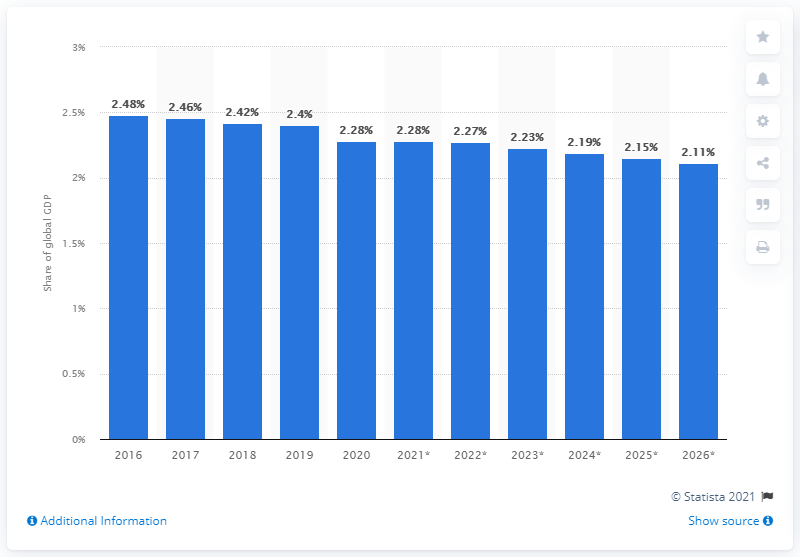List a handful of essential elements in this visual. In 2020, France's share of global GDP was 2.27%. 